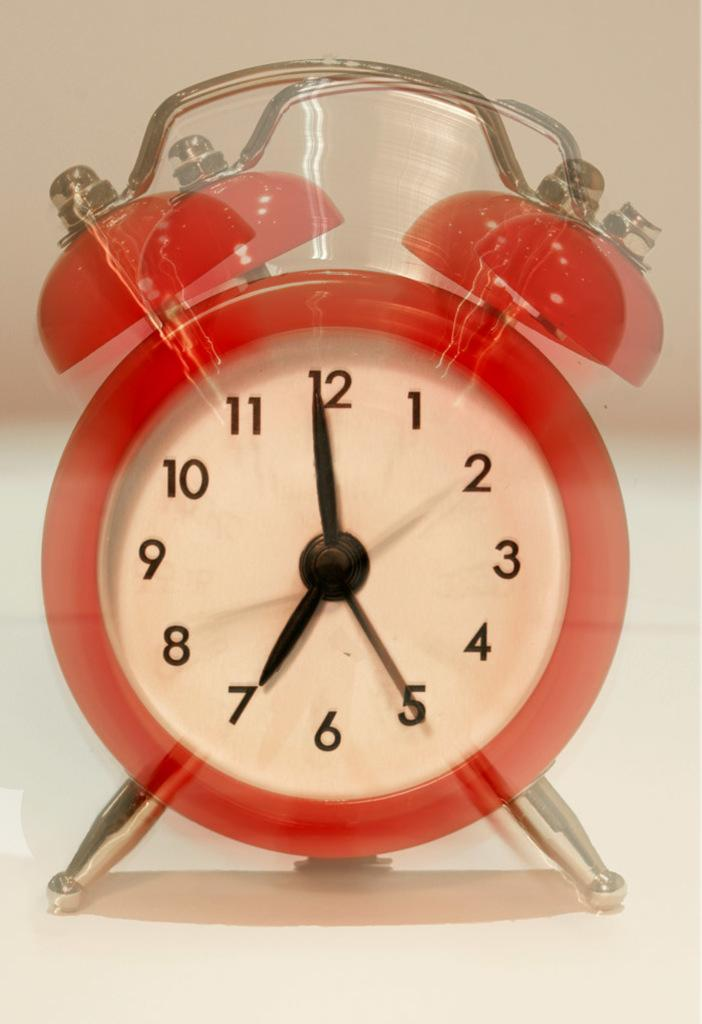<image>
Give a short and clear explanation of the subsequent image. Red alarm clock with bells on top seems like it's ringing at 7 o'clock. 